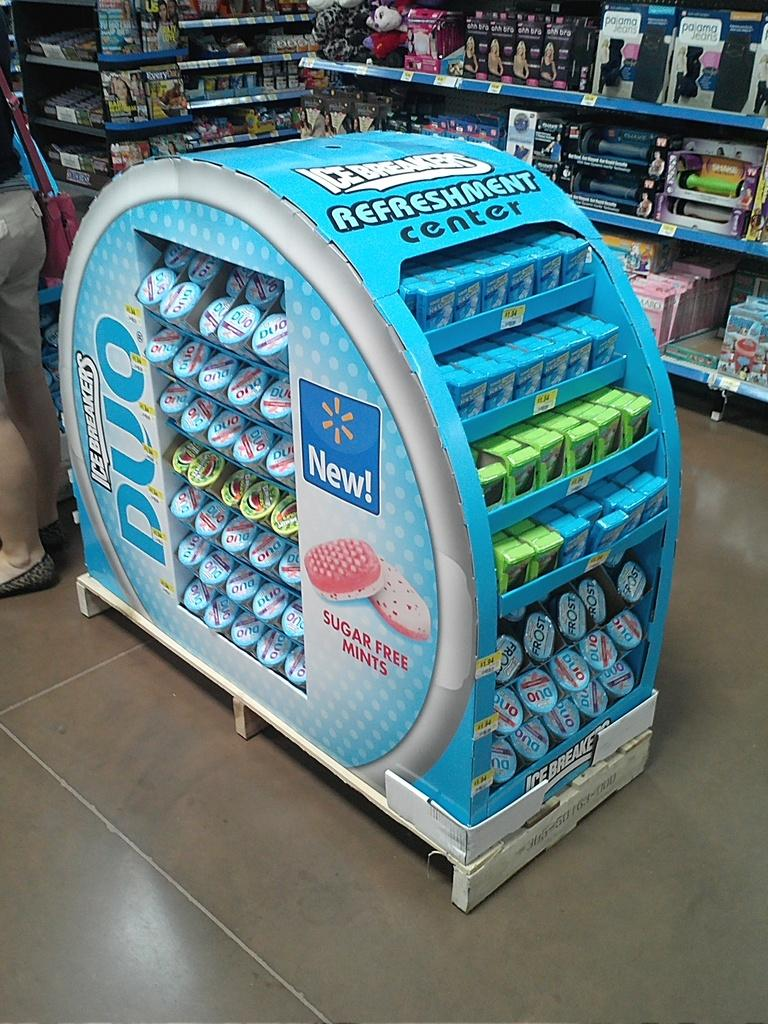<image>
Offer a succinct explanation of the picture presented. Large display for Ice Breakers on front of a store. 